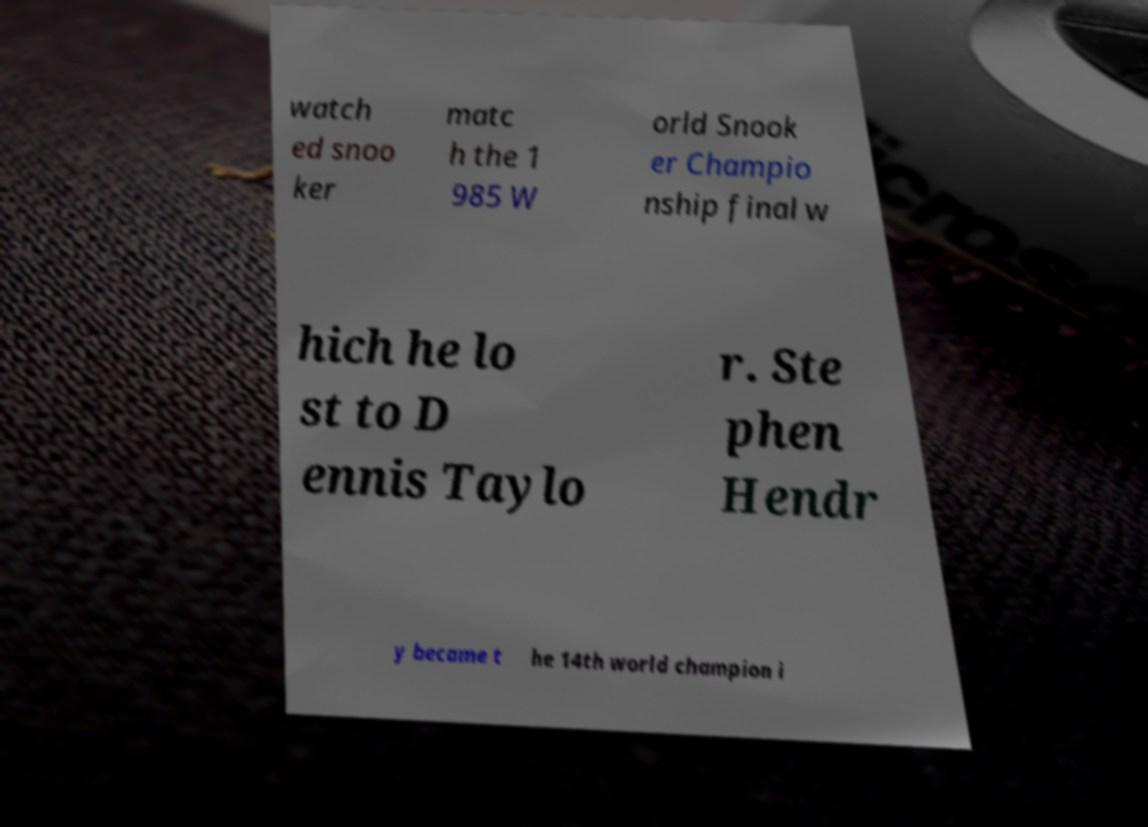Could you assist in decoding the text presented in this image and type it out clearly? watch ed snoo ker matc h the 1 985 W orld Snook er Champio nship final w hich he lo st to D ennis Taylo r. Ste phen Hendr y became t he 14th world champion i 